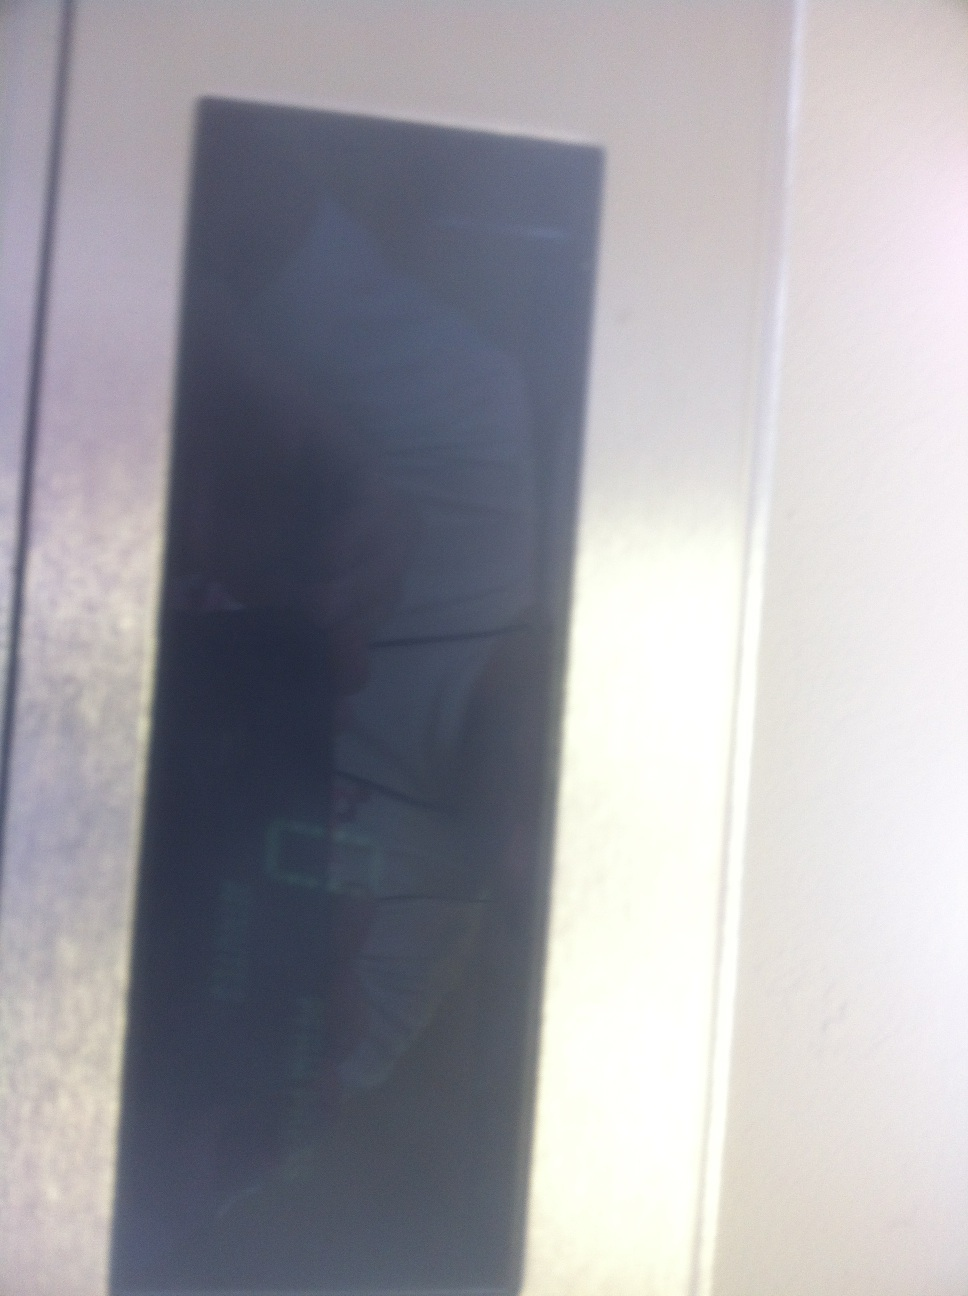What does the display say? It is difficult to accurately read the display in the image due to glare and reflection. From the limited view, it seems to contain some digital or numerical information, but the text is not clearly visible. 